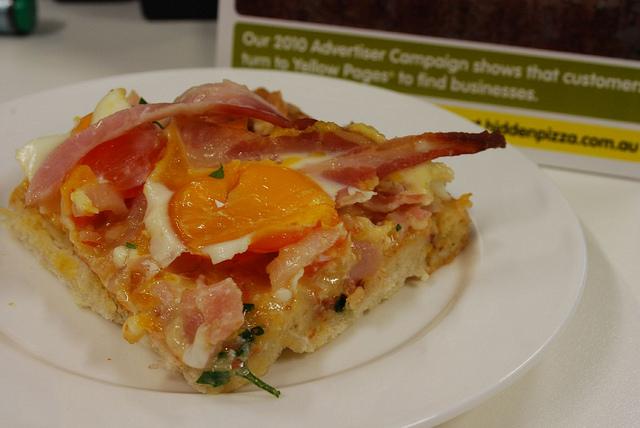Is this an Australian pizza place?
Concise answer only. Yes. Is the meal healthy?
Concise answer only. Yes. What kind of pizza is this?
Write a very short answer. Ham bacon. Are there two different types of food on the plate?
Keep it brief. No. Is there bacon on the pizza?
Short answer required. Yes. 